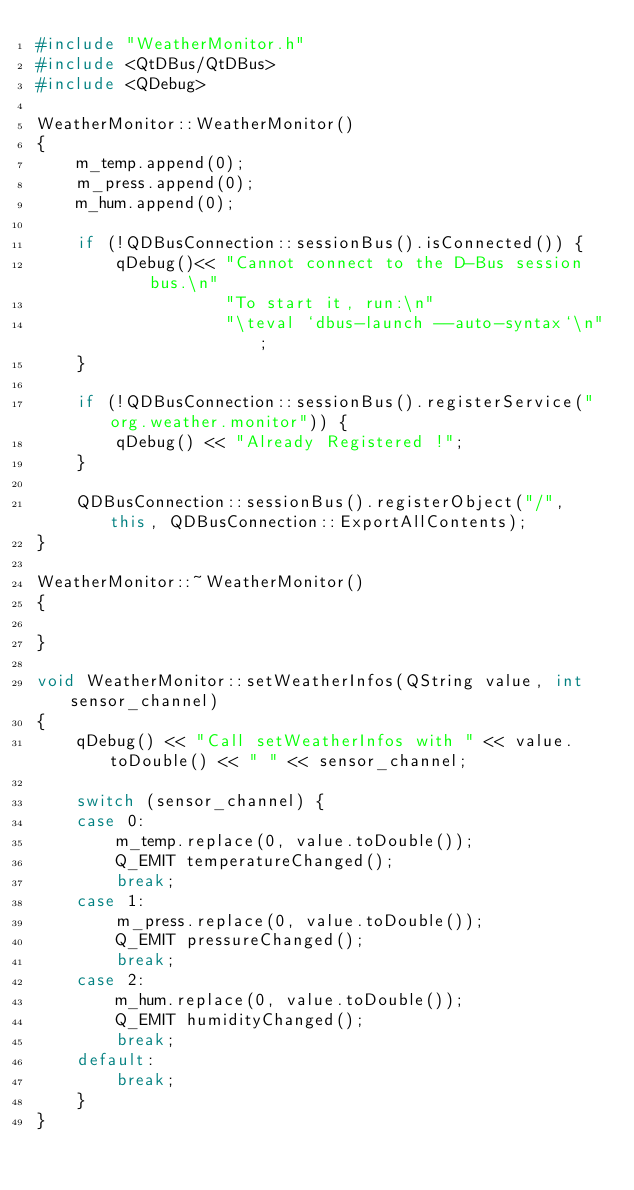<code> <loc_0><loc_0><loc_500><loc_500><_C++_>#include "WeatherMonitor.h"
#include <QtDBus/QtDBus>
#include <QDebug>

WeatherMonitor::WeatherMonitor()
{
    m_temp.append(0);
    m_press.append(0);
    m_hum.append(0);

    if (!QDBusConnection::sessionBus().isConnected()) {
        qDebug()<< "Cannot connect to the D-Bus session bus.\n"
                   "To start it, run:\n"
                   "\teval `dbus-launch --auto-syntax`\n";
    }

    if (!QDBusConnection::sessionBus().registerService("org.weather.monitor")) {
        qDebug() << "Already Registered !";
    }

    QDBusConnection::sessionBus().registerObject("/", this, QDBusConnection::ExportAllContents);
}

WeatherMonitor::~WeatherMonitor()
{

}

void WeatherMonitor::setWeatherInfos(QString value, int sensor_channel)
{
    qDebug() << "Call setWeatherInfos with " << value.toDouble() << " " << sensor_channel;

    switch (sensor_channel) {
    case 0:
        m_temp.replace(0, value.toDouble());
        Q_EMIT temperatureChanged();
        break;
    case 1:
        m_press.replace(0, value.toDouble());
        Q_EMIT pressureChanged();
        break;
    case 2:
        m_hum.replace(0, value.toDouble());
        Q_EMIT humidityChanged();
        break;
    default:
        break;
    }
}
</code> 